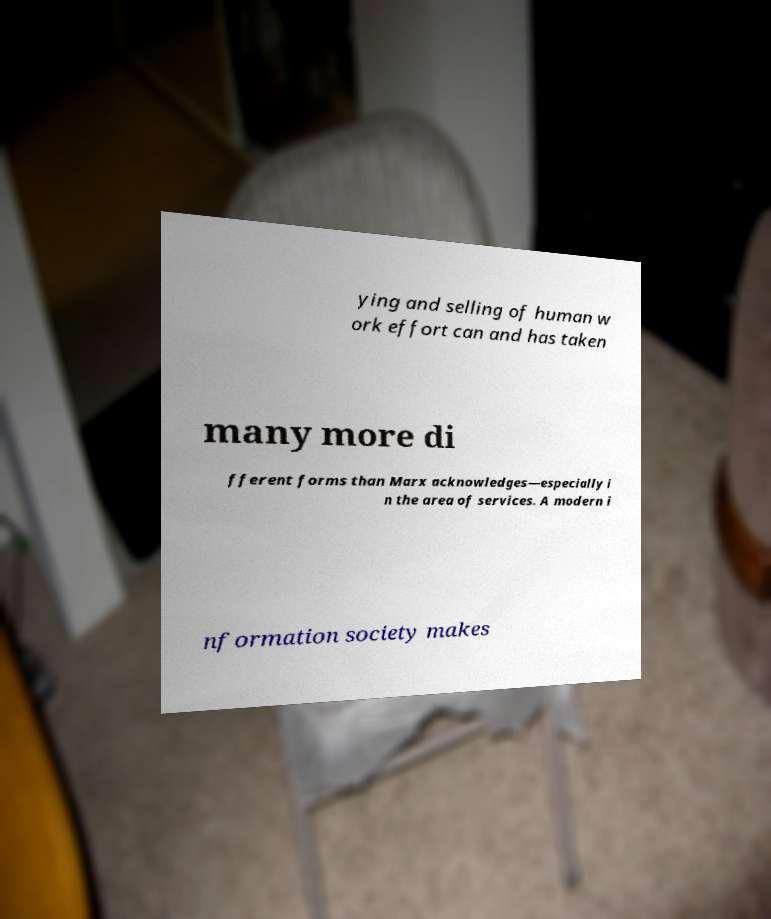Can you read and provide the text displayed in the image?This photo seems to have some interesting text. Can you extract and type it out for me? ying and selling of human w ork effort can and has taken many more di fferent forms than Marx acknowledges—especially i n the area of services. A modern i nformation society makes 